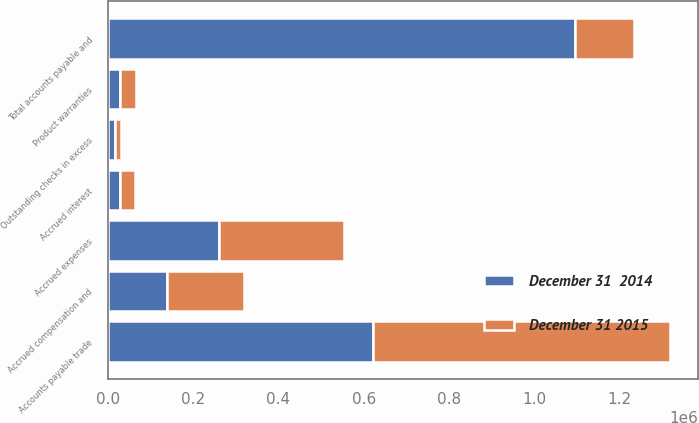<chart> <loc_0><loc_0><loc_500><loc_500><stacked_bar_chart><ecel><fcel>Outstanding checks in excess<fcel>Accounts payable trade<fcel>Accrued expenses<fcel>Product warranties<fcel>Accrued interest<fcel>Accrued compensation and<fcel>Total accounts payable and<nl><fcel>December 31 2015<fcel>14023<fcel>696974<fcel>293867<fcel>35516<fcel>34623<fcel>181022<fcel>138683<nl><fcel>December 31  2014<fcel>16083<fcel>622360<fcel>260578<fcel>29350<fcel>28365<fcel>138683<fcel>1.09542e+06<nl></chart> 